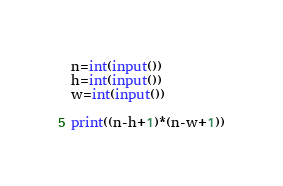<code> <loc_0><loc_0><loc_500><loc_500><_Python_>n=int(input())
h=int(input())
w=int(input())

print((n-h+1)*(n-w+1))</code> 